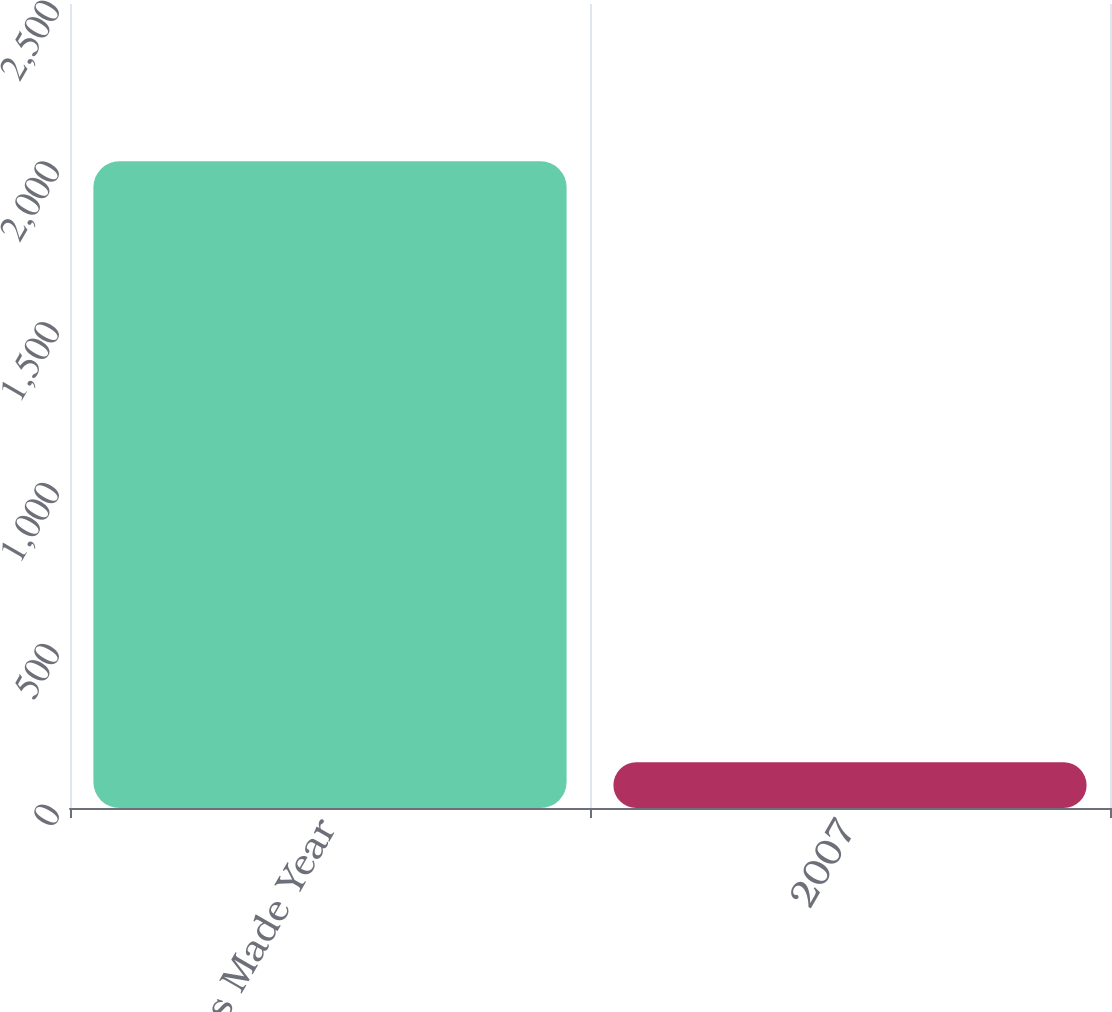<chart> <loc_0><loc_0><loc_500><loc_500><bar_chart><fcel>Claims Made Year<fcel>2007<nl><fcel>2011<fcel>142<nl></chart> 